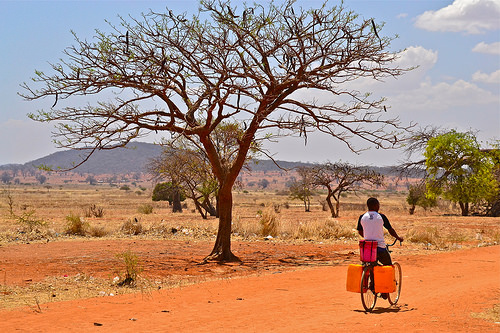<image>
Can you confirm if the tree is in front of the man? No. The tree is not in front of the man. The spatial positioning shows a different relationship between these objects. 